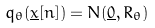<formula> <loc_0><loc_0><loc_500><loc_500>q _ { \theta } ( \underline { x } [ n ] ) = N ( \underline { 0 } , R _ { \theta } )</formula> 